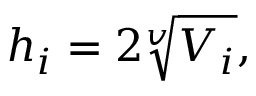<formula> <loc_0><loc_0><loc_500><loc_500>h _ { i } = 2 \sqrt { [ } v ] { V _ { i } } ,</formula> 